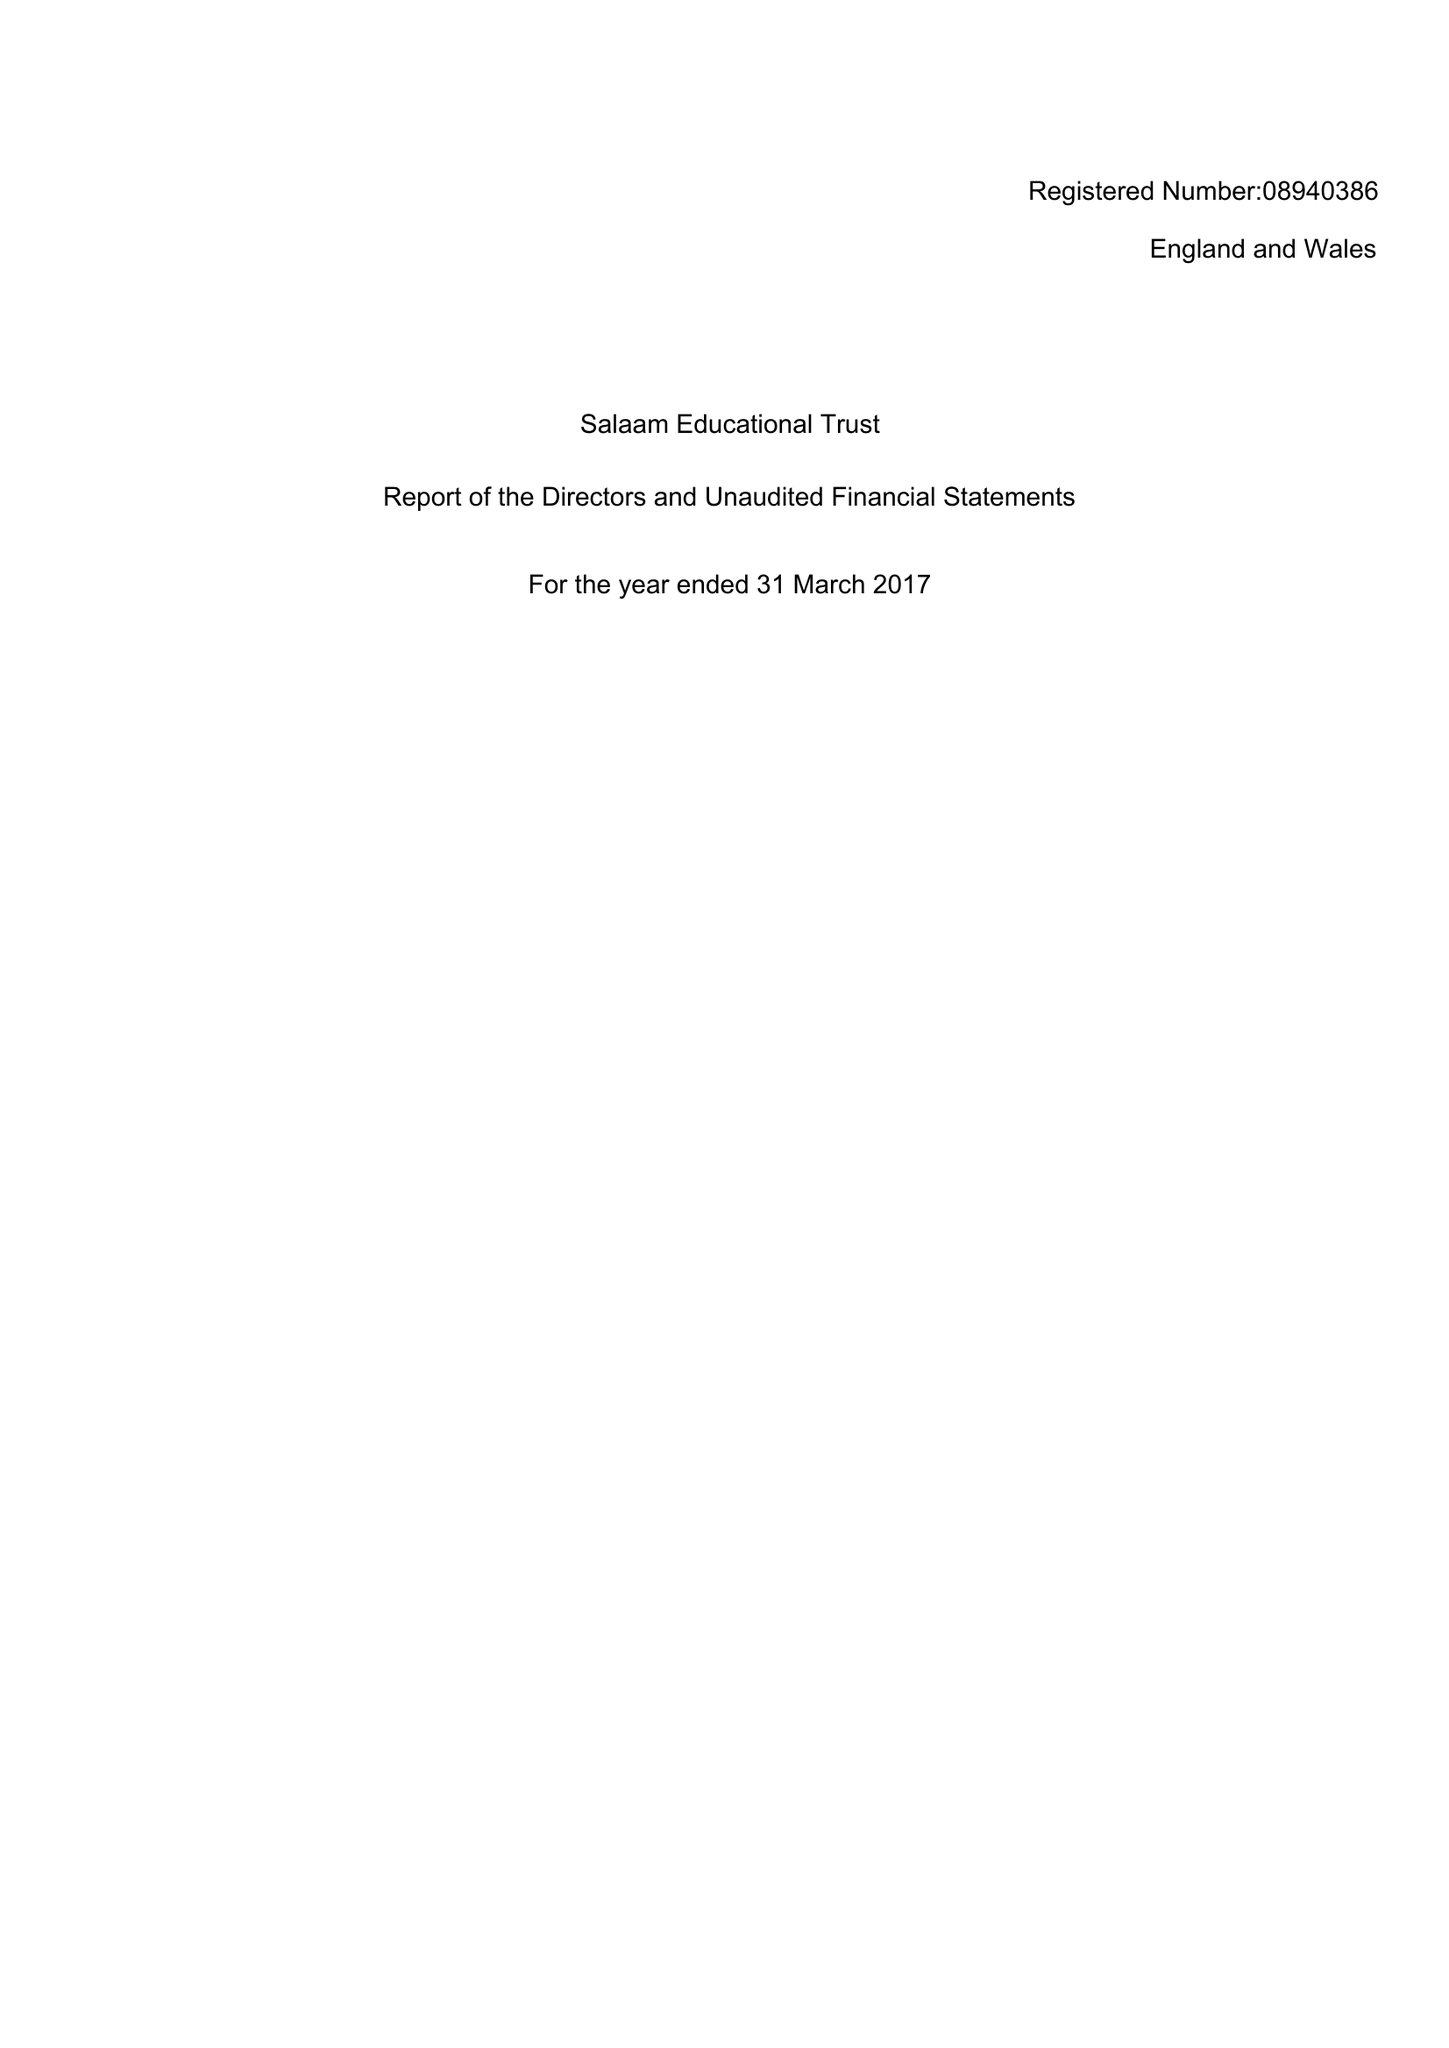What is the value for the charity_number?
Answer the question using a single word or phrase. 1159038 